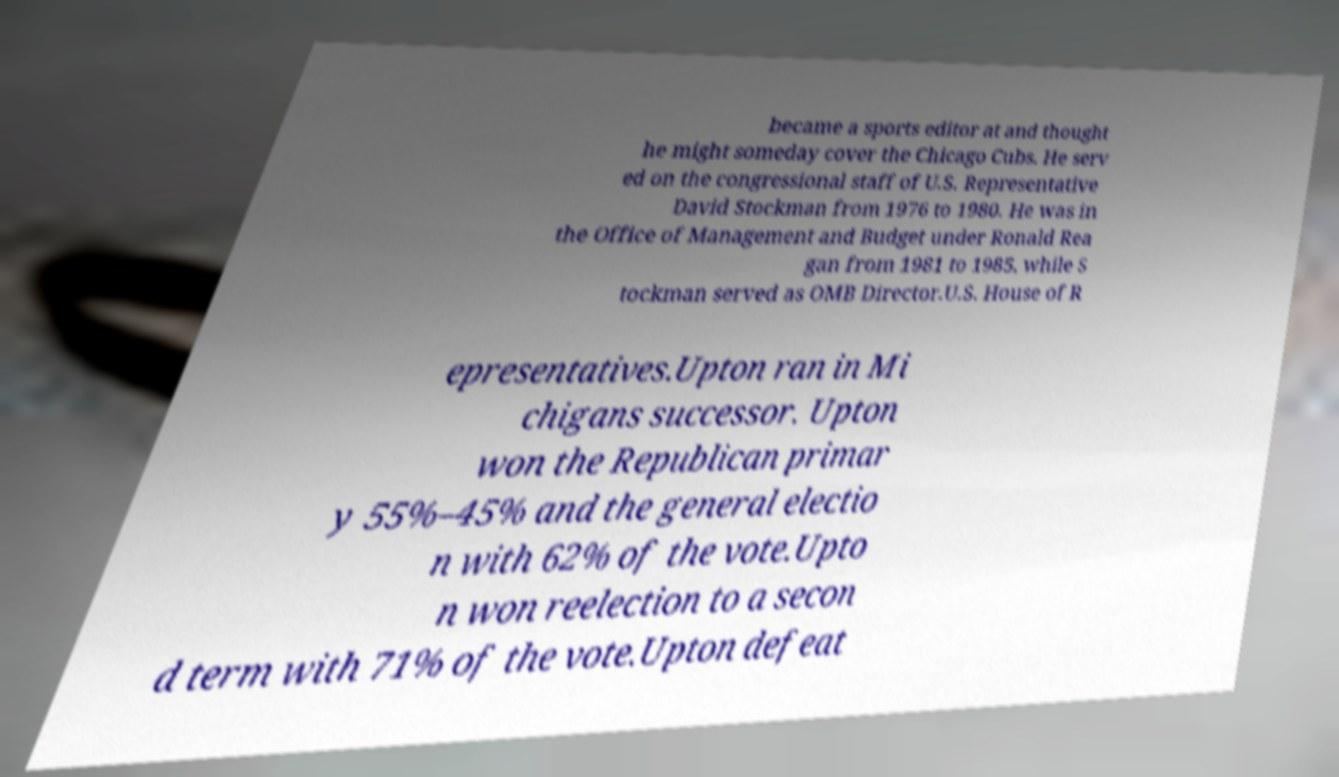For documentation purposes, I need the text within this image transcribed. Could you provide that? became a sports editor at and thought he might someday cover the Chicago Cubs. He serv ed on the congressional staff of U.S. Representative David Stockman from 1976 to 1980. He was in the Office of Management and Budget under Ronald Rea gan from 1981 to 1985, while S tockman served as OMB Director.U.S. House of R epresentatives.Upton ran in Mi chigans successor. Upton won the Republican primar y 55%–45% and the general electio n with 62% of the vote.Upto n won reelection to a secon d term with 71% of the vote.Upton defeat 